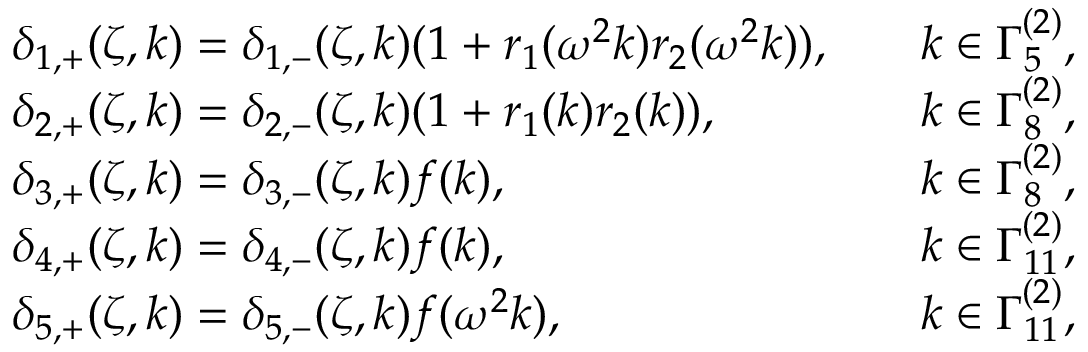<formula> <loc_0><loc_0><loc_500><loc_500>\begin{array} { r l r l } & { \delta _ { 1 , + } ( \zeta , k ) = \delta _ { 1 , - } ( \zeta , k ) ( 1 + r _ { 1 } ( \omega ^ { 2 } k ) r _ { 2 } ( \omega ^ { 2 } k ) ) , } & & { k \in \Gamma _ { 5 } ^ { ( 2 ) } , } \\ & { \delta _ { 2 , + } ( \zeta , k ) = \delta _ { 2 , - } ( \zeta , k ) ( 1 + r _ { 1 } ( k ) r _ { 2 } ( k ) ) , } & & { k \in \Gamma _ { 8 } ^ { ( 2 ) } , } \\ & { \delta _ { 3 , + } ( \zeta , k ) = \delta _ { 3 , - } ( \zeta , k ) f ( k ) , } & & { k \in \Gamma _ { 8 } ^ { ( 2 ) } , } \\ & { \delta _ { 4 , + } ( \zeta , k ) = \delta _ { 4 , - } ( \zeta , k ) f ( k ) , } & & { k \in \Gamma _ { 1 1 } ^ { ( 2 ) } , } \\ & { \delta _ { 5 , + } ( \zeta , k ) = \delta _ { 5 , - } ( \zeta , k ) f ( \omega ^ { 2 } k ) , } & & { k \in \Gamma _ { 1 1 } ^ { ( 2 ) } , } \end{array}</formula> 